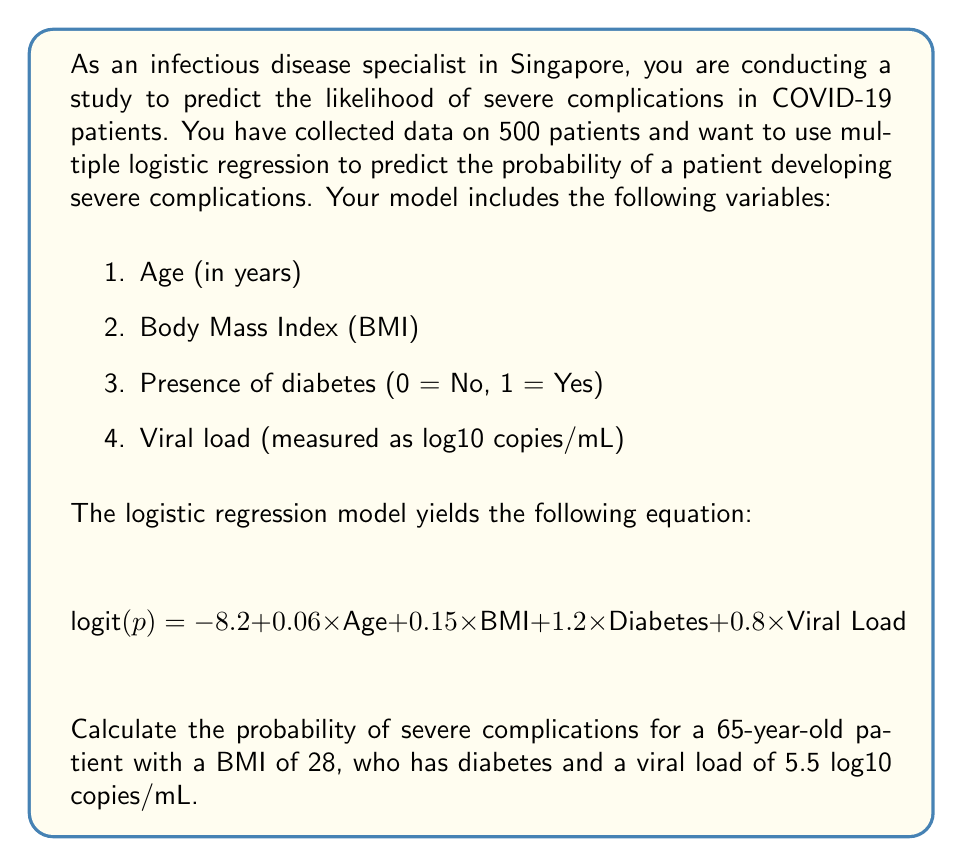Teach me how to tackle this problem. To solve this problem, we need to follow these steps:

1. Understand the logistic regression equation:
   The equation given is in the form of logit(p), where p is the probability of severe complications. The logit function is defined as:
   
   $$ \text{logit}(p) = \ln\left(\frac{p}{1-p}\right) $$

2. Substitute the given values into the equation:
   Age = 65
   BMI = 28
   Diabetes = 1 (Yes)
   Viral Load = 5.5

   $$ \text{logit}(p) = -8.2 + 0.06 \times 65 + 0.15 \times 28 + 1.2 \times 1 + 0.8 \times 5.5 $$

3. Calculate the logit(p):
   $$ \text{logit}(p) = -8.2 + 3.9 + 4.2 + 1.2 + 4.4 = 5.5 $$

4. Convert logit(p) to probability:
   To get the probability, we need to use the inverse logit function:
   
   $$ p = \frac{e^{\text{logit}(p)}}{1 + e^{\text{logit}(p)}} $$

   Where $e$ is the base of natural logarithms (approximately 2.71828).

5. Calculate the final probability:
   $$ p = \frac{e^{5.5}}{1 + e^{5.5}} $$
   $$ p = \frac{244.6919}{245.6919} $$
   $$ p \approx 0.9959 $$

6. Convert to percentage:
   0.9959 × 100% = 99.59%
Answer: The probability of severe complications for the given patient is approximately 99.59%. 